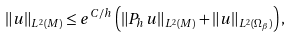<formula> <loc_0><loc_0><loc_500><loc_500>\left \| u \right \| _ { L ^ { 2 } ( M ) } \leq e ^ { C / h } \left ( \left \| P _ { h } u \right \| _ { L ^ { 2 } ( M ) } + \left \| u \right \| _ { L ^ { 2 } ( \Omega _ { \beta } ) } \right ) ,</formula> 